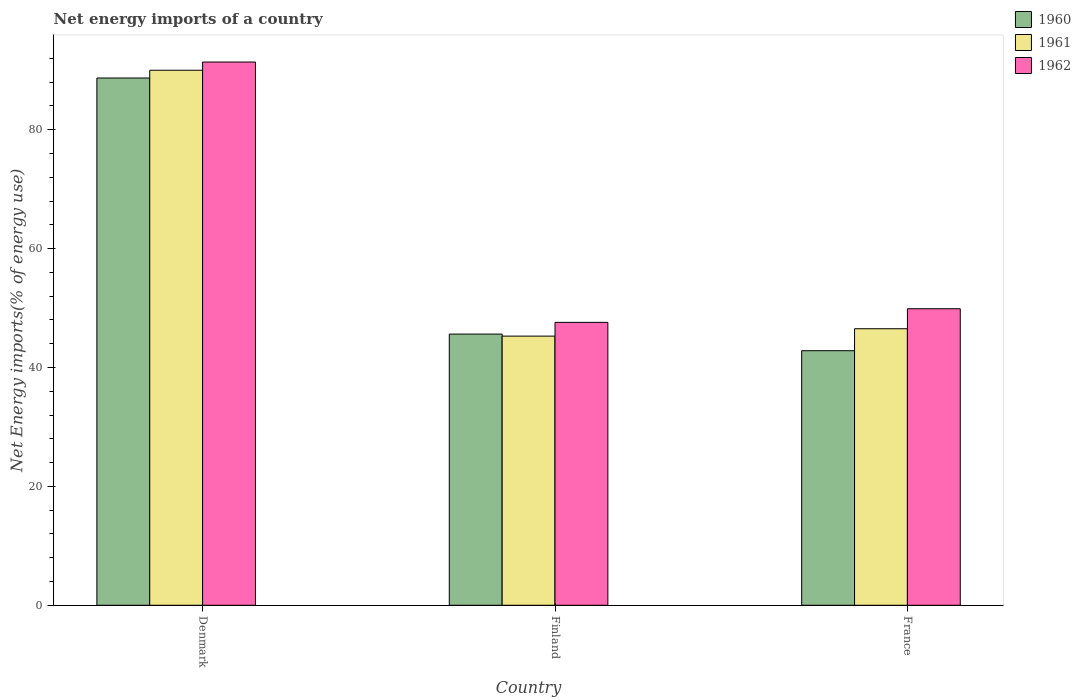How many different coloured bars are there?
Provide a succinct answer. 3. Are the number of bars on each tick of the X-axis equal?
Your answer should be compact. Yes. How many bars are there on the 1st tick from the left?
Your answer should be very brief. 3. How many bars are there on the 1st tick from the right?
Keep it short and to the point. 3. In how many cases, is the number of bars for a given country not equal to the number of legend labels?
Your response must be concise. 0. What is the net energy imports in 1961 in Finland?
Your response must be concise. 45.28. Across all countries, what is the maximum net energy imports in 1960?
Offer a very short reply. 88.7. Across all countries, what is the minimum net energy imports in 1960?
Ensure brevity in your answer.  42.82. In which country was the net energy imports in 1961 maximum?
Ensure brevity in your answer.  Denmark. What is the total net energy imports in 1961 in the graph?
Your answer should be compact. 181.81. What is the difference between the net energy imports in 1962 in Denmark and that in Finland?
Offer a very short reply. 43.8. What is the difference between the net energy imports in 1962 in Finland and the net energy imports in 1960 in France?
Give a very brief answer. 4.77. What is the average net energy imports in 1961 per country?
Offer a very short reply. 60.6. What is the difference between the net energy imports of/in 1961 and net energy imports of/in 1960 in Finland?
Offer a terse response. -0.34. What is the ratio of the net energy imports in 1961 in Denmark to that in Finland?
Offer a very short reply. 1.99. Is the difference between the net energy imports in 1961 in Denmark and France greater than the difference between the net energy imports in 1960 in Denmark and France?
Keep it short and to the point. No. What is the difference between the highest and the second highest net energy imports in 1962?
Make the answer very short. -41.5. What is the difference between the highest and the lowest net energy imports in 1960?
Offer a terse response. 45.88. Is the sum of the net energy imports in 1960 in Denmark and Finland greater than the maximum net energy imports in 1962 across all countries?
Your answer should be compact. Yes. What does the 2nd bar from the right in Denmark represents?
Make the answer very short. 1961. How many bars are there?
Give a very brief answer. 9. How many countries are there in the graph?
Give a very brief answer. 3. Where does the legend appear in the graph?
Give a very brief answer. Top right. How many legend labels are there?
Offer a terse response. 3. How are the legend labels stacked?
Provide a succinct answer. Vertical. What is the title of the graph?
Give a very brief answer. Net energy imports of a country. What is the label or title of the X-axis?
Provide a succinct answer. Country. What is the label or title of the Y-axis?
Keep it short and to the point. Net Energy imports(% of energy use). What is the Net Energy imports(% of energy use) in 1960 in Denmark?
Offer a very short reply. 88.7. What is the Net Energy imports(% of energy use) of 1961 in Denmark?
Your answer should be very brief. 90.01. What is the Net Energy imports(% of energy use) of 1962 in Denmark?
Your answer should be compact. 91.39. What is the Net Energy imports(% of energy use) in 1960 in Finland?
Provide a succinct answer. 45.62. What is the Net Energy imports(% of energy use) of 1961 in Finland?
Offer a very short reply. 45.28. What is the Net Energy imports(% of energy use) of 1962 in Finland?
Make the answer very short. 47.59. What is the Net Energy imports(% of energy use) in 1960 in France?
Make the answer very short. 42.82. What is the Net Energy imports(% of energy use) of 1961 in France?
Your answer should be very brief. 46.52. What is the Net Energy imports(% of energy use) in 1962 in France?
Provide a short and direct response. 49.89. Across all countries, what is the maximum Net Energy imports(% of energy use) of 1960?
Make the answer very short. 88.7. Across all countries, what is the maximum Net Energy imports(% of energy use) of 1961?
Your response must be concise. 90.01. Across all countries, what is the maximum Net Energy imports(% of energy use) in 1962?
Provide a succinct answer. 91.39. Across all countries, what is the minimum Net Energy imports(% of energy use) of 1960?
Your response must be concise. 42.82. Across all countries, what is the minimum Net Energy imports(% of energy use) in 1961?
Give a very brief answer. 45.28. Across all countries, what is the minimum Net Energy imports(% of energy use) of 1962?
Your response must be concise. 47.59. What is the total Net Energy imports(% of energy use) of 1960 in the graph?
Offer a terse response. 177.14. What is the total Net Energy imports(% of energy use) of 1961 in the graph?
Your response must be concise. 181.81. What is the total Net Energy imports(% of energy use) of 1962 in the graph?
Provide a succinct answer. 188.87. What is the difference between the Net Energy imports(% of energy use) of 1960 in Denmark and that in Finland?
Your answer should be very brief. 43.08. What is the difference between the Net Energy imports(% of energy use) in 1961 in Denmark and that in Finland?
Your answer should be very brief. 44.73. What is the difference between the Net Energy imports(% of energy use) in 1962 in Denmark and that in Finland?
Offer a terse response. 43.8. What is the difference between the Net Energy imports(% of energy use) in 1960 in Denmark and that in France?
Offer a terse response. 45.88. What is the difference between the Net Energy imports(% of energy use) in 1961 in Denmark and that in France?
Ensure brevity in your answer.  43.49. What is the difference between the Net Energy imports(% of energy use) in 1962 in Denmark and that in France?
Offer a terse response. 41.5. What is the difference between the Net Energy imports(% of energy use) of 1960 in Finland and that in France?
Offer a terse response. 2.8. What is the difference between the Net Energy imports(% of energy use) in 1961 in Finland and that in France?
Offer a terse response. -1.24. What is the difference between the Net Energy imports(% of energy use) of 1962 in Finland and that in France?
Give a very brief answer. -2.3. What is the difference between the Net Energy imports(% of energy use) of 1960 in Denmark and the Net Energy imports(% of energy use) of 1961 in Finland?
Ensure brevity in your answer.  43.42. What is the difference between the Net Energy imports(% of energy use) in 1960 in Denmark and the Net Energy imports(% of energy use) in 1962 in Finland?
Ensure brevity in your answer.  41.11. What is the difference between the Net Energy imports(% of energy use) in 1961 in Denmark and the Net Energy imports(% of energy use) in 1962 in Finland?
Provide a succinct answer. 42.42. What is the difference between the Net Energy imports(% of energy use) in 1960 in Denmark and the Net Energy imports(% of energy use) in 1961 in France?
Offer a terse response. 42.18. What is the difference between the Net Energy imports(% of energy use) in 1960 in Denmark and the Net Energy imports(% of energy use) in 1962 in France?
Your response must be concise. 38.81. What is the difference between the Net Energy imports(% of energy use) of 1961 in Denmark and the Net Energy imports(% of energy use) of 1962 in France?
Offer a terse response. 40.12. What is the difference between the Net Energy imports(% of energy use) in 1960 in Finland and the Net Energy imports(% of energy use) in 1961 in France?
Provide a succinct answer. -0.9. What is the difference between the Net Energy imports(% of energy use) of 1960 in Finland and the Net Energy imports(% of energy use) of 1962 in France?
Your answer should be very brief. -4.27. What is the difference between the Net Energy imports(% of energy use) in 1961 in Finland and the Net Energy imports(% of energy use) in 1962 in France?
Keep it short and to the point. -4.61. What is the average Net Energy imports(% of energy use) in 1960 per country?
Your answer should be very brief. 59.05. What is the average Net Energy imports(% of energy use) of 1961 per country?
Provide a short and direct response. 60.6. What is the average Net Energy imports(% of energy use) of 1962 per country?
Provide a short and direct response. 62.96. What is the difference between the Net Energy imports(% of energy use) in 1960 and Net Energy imports(% of energy use) in 1961 in Denmark?
Offer a very short reply. -1.31. What is the difference between the Net Energy imports(% of energy use) of 1960 and Net Energy imports(% of energy use) of 1962 in Denmark?
Provide a short and direct response. -2.69. What is the difference between the Net Energy imports(% of energy use) of 1961 and Net Energy imports(% of energy use) of 1962 in Denmark?
Offer a terse response. -1.38. What is the difference between the Net Energy imports(% of energy use) of 1960 and Net Energy imports(% of energy use) of 1961 in Finland?
Make the answer very short. 0.34. What is the difference between the Net Energy imports(% of energy use) of 1960 and Net Energy imports(% of energy use) of 1962 in Finland?
Give a very brief answer. -1.97. What is the difference between the Net Energy imports(% of energy use) in 1961 and Net Energy imports(% of energy use) in 1962 in Finland?
Provide a succinct answer. -2.31. What is the difference between the Net Energy imports(% of energy use) of 1960 and Net Energy imports(% of energy use) of 1961 in France?
Provide a succinct answer. -3.7. What is the difference between the Net Energy imports(% of energy use) in 1960 and Net Energy imports(% of energy use) in 1962 in France?
Provide a short and direct response. -7.06. What is the difference between the Net Energy imports(% of energy use) in 1961 and Net Energy imports(% of energy use) in 1962 in France?
Offer a very short reply. -3.37. What is the ratio of the Net Energy imports(% of energy use) in 1960 in Denmark to that in Finland?
Your answer should be compact. 1.94. What is the ratio of the Net Energy imports(% of energy use) of 1961 in Denmark to that in Finland?
Ensure brevity in your answer.  1.99. What is the ratio of the Net Energy imports(% of energy use) of 1962 in Denmark to that in Finland?
Make the answer very short. 1.92. What is the ratio of the Net Energy imports(% of energy use) of 1960 in Denmark to that in France?
Your answer should be very brief. 2.07. What is the ratio of the Net Energy imports(% of energy use) of 1961 in Denmark to that in France?
Ensure brevity in your answer.  1.93. What is the ratio of the Net Energy imports(% of energy use) in 1962 in Denmark to that in France?
Your response must be concise. 1.83. What is the ratio of the Net Energy imports(% of energy use) in 1960 in Finland to that in France?
Offer a very short reply. 1.07. What is the ratio of the Net Energy imports(% of energy use) of 1961 in Finland to that in France?
Ensure brevity in your answer.  0.97. What is the ratio of the Net Energy imports(% of energy use) of 1962 in Finland to that in France?
Make the answer very short. 0.95. What is the difference between the highest and the second highest Net Energy imports(% of energy use) in 1960?
Provide a short and direct response. 43.08. What is the difference between the highest and the second highest Net Energy imports(% of energy use) in 1961?
Make the answer very short. 43.49. What is the difference between the highest and the second highest Net Energy imports(% of energy use) in 1962?
Provide a succinct answer. 41.5. What is the difference between the highest and the lowest Net Energy imports(% of energy use) in 1960?
Provide a succinct answer. 45.88. What is the difference between the highest and the lowest Net Energy imports(% of energy use) of 1961?
Provide a short and direct response. 44.73. What is the difference between the highest and the lowest Net Energy imports(% of energy use) in 1962?
Give a very brief answer. 43.8. 